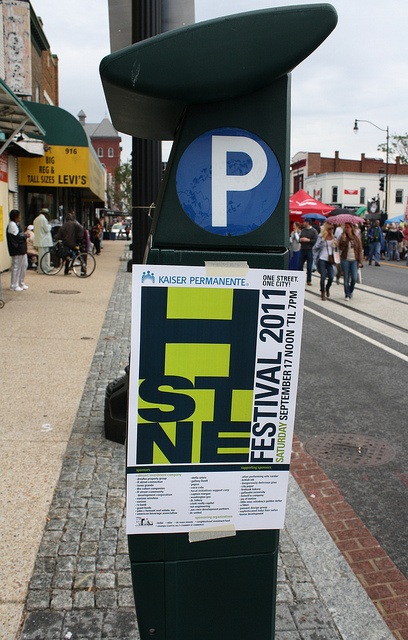<image>What city is this? I don't know what city this is. It could be San Antonio, Hollywood, London, California, or New York. What city is this? I am not sure what city is this. It can be San Antonio, Saturn or Hollywood. 